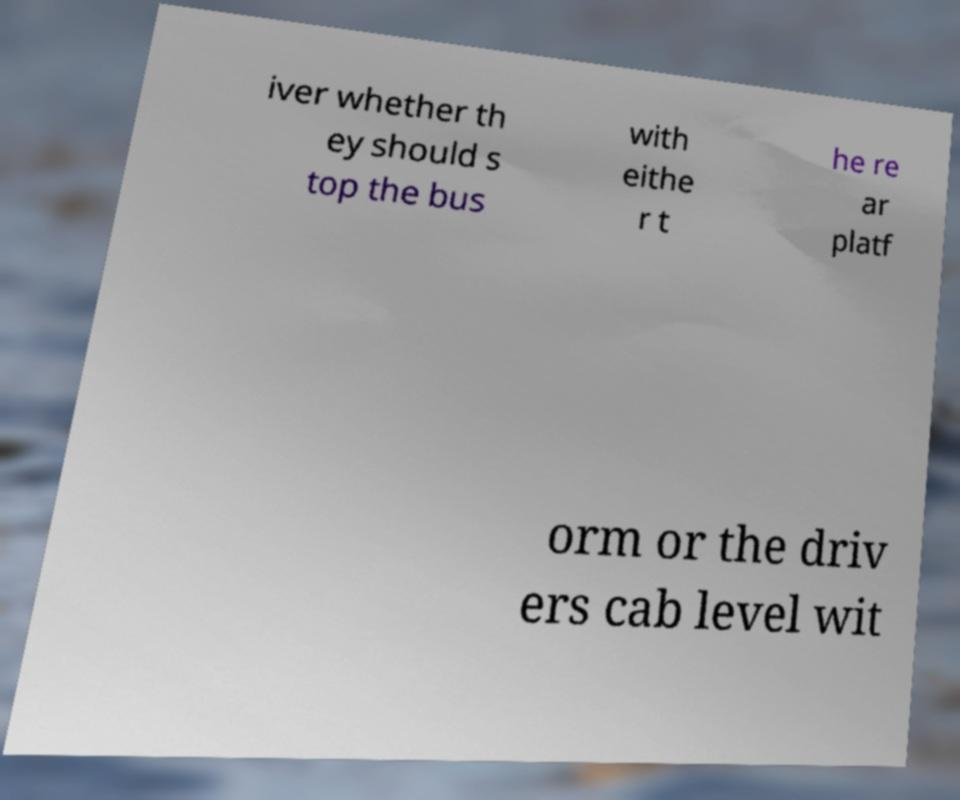For documentation purposes, I need the text within this image transcribed. Could you provide that? iver whether th ey should s top the bus with eithe r t he re ar platf orm or the driv ers cab level wit 